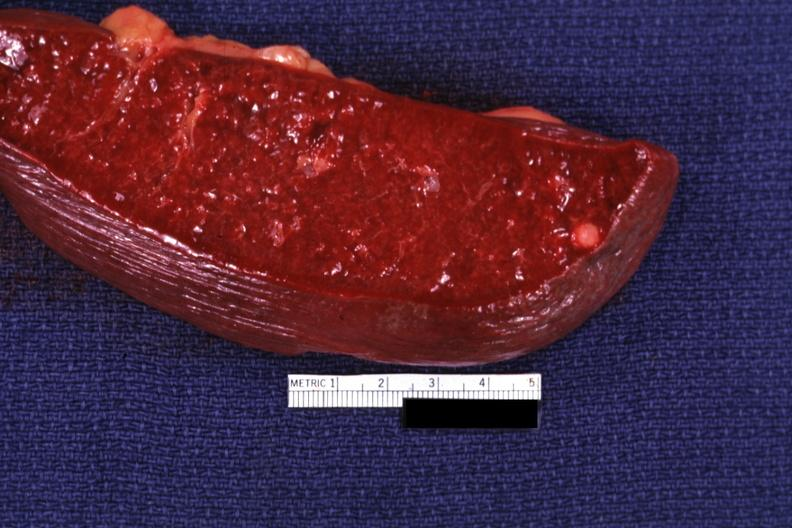s hematologic present?
Answer the question using a single word or phrase. Yes 